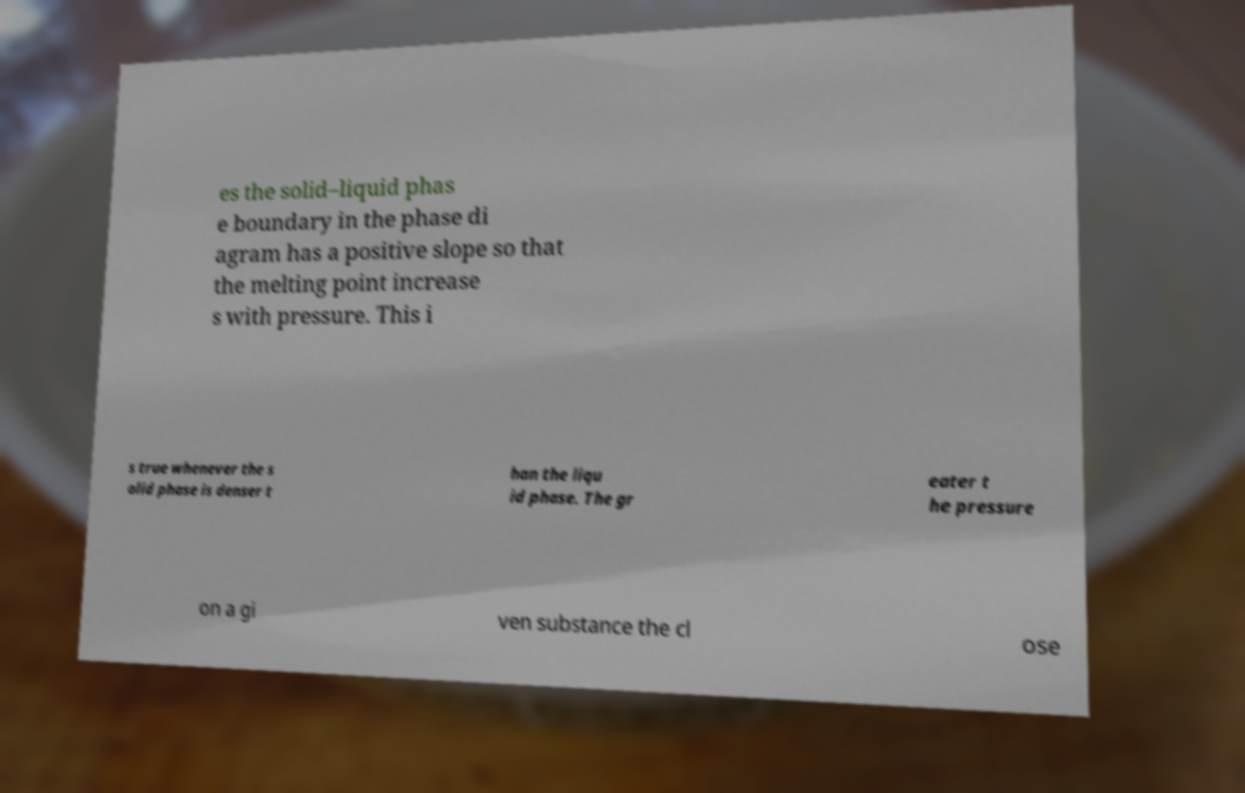Can you accurately transcribe the text from the provided image for me? es the solid–liquid phas e boundary in the phase di agram has a positive slope so that the melting point increase s with pressure. This i s true whenever the s olid phase is denser t han the liqu id phase. The gr eater t he pressure on a gi ven substance the cl ose 